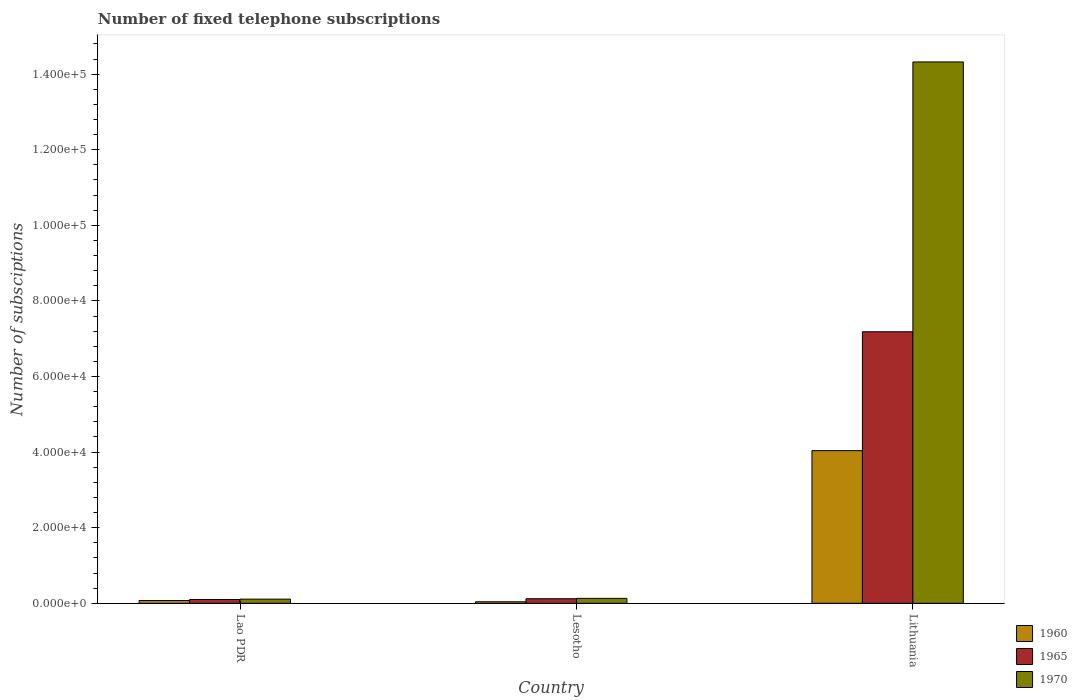How many groups of bars are there?
Provide a short and direct response. 3. Are the number of bars per tick equal to the number of legend labels?
Your answer should be compact. Yes. How many bars are there on the 2nd tick from the left?
Offer a very short reply. 3. What is the label of the 3rd group of bars from the left?
Keep it short and to the point. Lithuania. In how many cases, is the number of bars for a given country not equal to the number of legend labels?
Your answer should be very brief. 0. Across all countries, what is the maximum number of fixed telephone subscriptions in 1970?
Provide a succinct answer. 1.43e+05. In which country was the number of fixed telephone subscriptions in 1970 maximum?
Provide a succinct answer. Lithuania. In which country was the number of fixed telephone subscriptions in 1965 minimum?
Offer a terse response. Lao PDR. What is the total number of fixed telephone subscriptions in 1970 in the graph?
Provide a succinct answer. 1.46e+05. What is the difference between the number of fixed telephone subscriptions in 1960 in Lao PDR and that in Lesotho?
Ensure brevity in your answer.  336. What is the difference between the number of fixed telephone subscriptions in 1965 in Lesotho and the number of fixed telephone subscriptions in 1970 in Lithuania?
Your answer should be very brief. -1.42e+05. What is the average number of fixed telephone subscriptions in 1960 per country?
Offer a terse response. 1.38e+04. What is the difference between the number of fixed telephone subscriptions of/in 1965 and number of fixed telephone subscriptions of/in 1960 in Lithuania?
Make the answer very short. 3.15e+04. In how many countries, is the number of fixed telephone subscriptions in 1960 greater than 16000?
Give a very brief answer. 1. What is the ratio of the number of fixed telephone subscriptions in 1970 in Lao PDR to that in Lesotho?
Offer a very short reply. 0.85. Is the difference between the number of fixed telephone subscriptions in 1965 in Lesotho and Lithuania greater than the difference between the number of fixed telephone subscriptions in 1960 in Lesotho and Lithuania?
Ensure brevity in your answer.  No. What is the difference between the highest and the second highest number of fixed telephone subscriptions in 1965?
Ensure brevity in your answer.  200. What is the difference between the highest and the lowest number of fixed telephone subscriptions in 1970?
Provide a succinct answer. 1.42e+05. In how many countries, is the number of fixed telephone subscriptions in 1970 greater than the average number of fixed telephone subscriptions in 1970 taken over all countries?
Give a very brief answer. 1. What does the 2nd bar from the right in Lesotho represents?
Your answer should be compact. 1965. How many countries are there in the graph?
Make the answer very short. 3. Are the values on the major ticks of Y-axis written in scientific E-notation?
Provide a succinct answer. Yes. Does the graph contain grids?
Give a very brief answer. No. Where does the legend appear in the graph?
Your answer should be very brief. Bottom right. What is the title of the graph?
Provide a short and direct response. Number of fixed telephone subscriptions. Does "1998" appear as one of the legend labels in the graph?
Offer a very short reply. No. What is the label or title of the X-axis?
Your response must be concise. Country. What is the label or title of the Y-axis?
Your answer should be very brief. Number of subsciptions. What is the Number of subsciptions of 1960 in Lao PDR?
Provide a succinct answer. 736. What is the Number of subsciptions in 1970 in Lao PDR?
Your answer should be compact. 1100. What is the Number of subsciptions of 1965 in Lesotho?
Provide a succinct answer. 1200. What is the Number of subsciptions in 1970 in Lesotho?
Ensure brevity in your answer.  1300. What is the Number of subsciptions of 1960 in Lithuania?
Ensure brevity in your answer.  4.04e+04. What is the Number of subsciptions in 1965 in Lithuania?
Offer a terse response. 7.18e+04. What is the Number of subsciptions of 1970 in Lithuania?
Offer a terse response. 1.43e+05. Across all countries, what is the maximum Number of subsciptions in 1960?
Provide a short and direct response. 4.04e+04. Across all countries, what is the maximum Number of subsciptions of 1965?
Provide a succinct answer. 7.18e+04. Across all countries, what is the maximum Number of subsciptions in 1970?
Offer a very short reply. 1.43e+05. Across all countries, what is the minimum Number of subsciptions of 1960?
Your response must be concise. 400. Across all countries, what is the minimum Number of subsciptions of 1970?
Make the answer very short. 1100. What is the total Number of subsciptions in 1960 in the graph?
Ensure brevity in your answer.  4.15e+04. What is the total Number of subsciptions in 1965 in the graph?
Provide a succinct answer. 7.40e+04. What is the total Number of subsciptions of 1970 in the graph?
Your answer should be compact. 1.46e+05. What is the difference between the Number of subsciptions of 1960 in Lao PDR and that in Lesotho?
Your response must be concise. 336. What is the difference between the Number of subsciptions of 1965 in Lao PDR and that in Lesotho?
Your response must be concise. -200. What is the difference between the Number of subsciptions in 1970 in Lao PDR and that in Lesotho?
Offer a very short reply. -200. What is the difference between the Number of subsciptions in 1960 in Lao PDR and that in Lithuania?
Provide a succinct answer. -3.97e+04. What is the difference between the Number of subsciptions of 1965 in Lao PDR and that in Lithuania?
Your answer should be very brief. -7.08e+04. What is the difference between the Number of subsciptions in 1970 in Lao PDR and that in Lithuania?
Provide a short and direct response. -1.42e+05. What is the difference between the Number of subsciptions of 1960 in Lesotho and that in Lithuania?
Keep it short and to the point. -4.00e+04. What is the difference between the Number of subsciptions of 1965 in Lesotho and that in Lithuania?
Offer a terse response. -7.06e+04. What is the difference between the Number of subsciptions in 1970 in Lesotho and that in Lithuania?
Make the answer very short. -1.42e+05. What is the difference between the Number of subsciptions in 1960 in Lao PDR and the Number of subsciptions in 1965 in Lesotho?
Your answer should be very brief. -464. What is the difference between the Number of subsciptions of 1960 in Lao PDR and the Number of subsciptions of 1970 in Lesotho?
Your response must be concise. -564. What is the difference between the Number of subsciptions in 1965 in Lao PDR and the Number of subsciptions in 1970 in Lesotho?
Keep it short and to the point. -300. What is the difference between the Number of subsciptions in 1960 in Lao PDR and the Number of subsciptions in 1965 in Lithuania?
Offer a terse response. -7.11e+04. What is the difference between the Number of subsciptions in 1960 in Lao PDR and the Number of subsciptions in 1970 in Lithuania?
Keep it short and to the point. -1.42e+05. What is the difference between the Number of subsciptions in 1965 in Lao PDR and the Number of subsciptions in 1970 in Lithuania?
Provide a short and direct response. -1.42e+05. What is the difference between the Number of subsciptions in 1960 in Lesotho and the Number of subsciptions in 1965 in Lithuania?
Your answer should be compact. -7.14e+04. What is the difference between the Number of subsciptions of 1960 in Lesotho and the Number of subsciptions of 1970 in Lithuania?
Give a very brief answer. -1.43e+05. What is the difference between the Number of subsciptions of 1965 in Lesotho and the Number of subsciptions of 1970 in Lithuania?
Make the answer very short. -1.42e+05. What is the average Number of subsciptions of 1960 per country?
Your answer should be compact. 1.38e+04. What is the average Number of subsciptions of 1965 per country?
Give a very brief answer. 2.47e+04. What is the average Number of subsciptions of 1970 per country?
Your answer should be compact. 4.85e+04. What is the difference between the Number of subsciptions of 1960 and Number of subsciptions of 1965 in Lao PDR?
Offer a terse response. -264. What is the difference between the Number of subsciptions in 1960 and Number of subsciptions in 1970 in Lao PDR?
Offer a terse response. -364. What is the difference between the Number of subsciptions in 1965 and Number of subsciptions in 1970 in Lao PDR?
Make the answer very short. -100. What is the difference between the Number of subsciptions in 1960 and Number of subsciptions in 1965 in Lesotho?
Provide a short and direct response. -800. What is the difference between the Number of subsciptions of 1960 and Number of subsciptions of 1970 in Lesotho?
Your response must be concise. -900. What is the difference between the Number of subsciptions in 1965 and Number of subsciptions in 1970 in Lesotho?
Your response must be concise. -100. What is the difference between the Number of subsciptions of 1960 and Number of subsciptions of 1965 in Lithuania?
Make the answer very short. -3.15e+04. What is the difference between the Number of subsciptions in 1960 and Number of subsciptions in 1970 in Lithuania?
Your answer should be compact. -1.03e+05. What is the difference between the Number of subsciptions of 1965 and Number of subsciptions of 1970 in Lithuania?
Make the answer very short. -7.14e+04. What is the ratio of the Number of subsciptions in 1960 in Lao PDR to that in Lesotho?
Offer a terse response. 1.84. What is the ratio of the Number of subsciptions in 1970 in Lao PDR to that in Lesotho?
Make the answer very short. 0.85. What is the ratio of the Number of subsciptions of 1960 in Lao PDR to that in Lithuania?
Ensure brevity in your answer.  0.02. What is the ratio of the Number of subsciptions in 1965 in Lao PDR to that in Lithuania?
Make the answer very short. 0.01. What is the ratio of the Number of subsciptions in 1970 in Lao PDR to that in Lithuania?
Make the answer very short. 0.01. What is the ratio of the Number of subsciptions of 1960 in Lesotho to that in Lithuania?
Give a very brief answer. 0.01. What is the ratio of the Number of subsciptions of 1965 in Lesotho to that in Lithuania?
Give a very brief answer. 0.02. What is the ratio of the Number of subsciptions in 1970 in Lesotho to that in Lithuania?
Your response must be concise. 0.01. What is the difference between the highest and the second highest Number of subsciptions of 1960?
Provide a succinct answer. 3.97e+04. What is the difference between the highest and the second highest Number of subsciptions of 1965?
Your answer should be very brief. 7.06e+04. What is the difference between the highest and the second highest Number of subsciptions in 1970?
Offer a terse response. 1.42e+05. What is the difference between the highest and the lowest Number of subsciptions in 1960?
Make the answer very short. 4.00e+04. What is the difference between the highest and the lowest Number of subsciptions in 1965?
Make the answer very short. 7.08e+04. What is the difference between the highest and the lowest Number of subsciptions of 1970?
Give a very brief answer. 1.42e+05. 